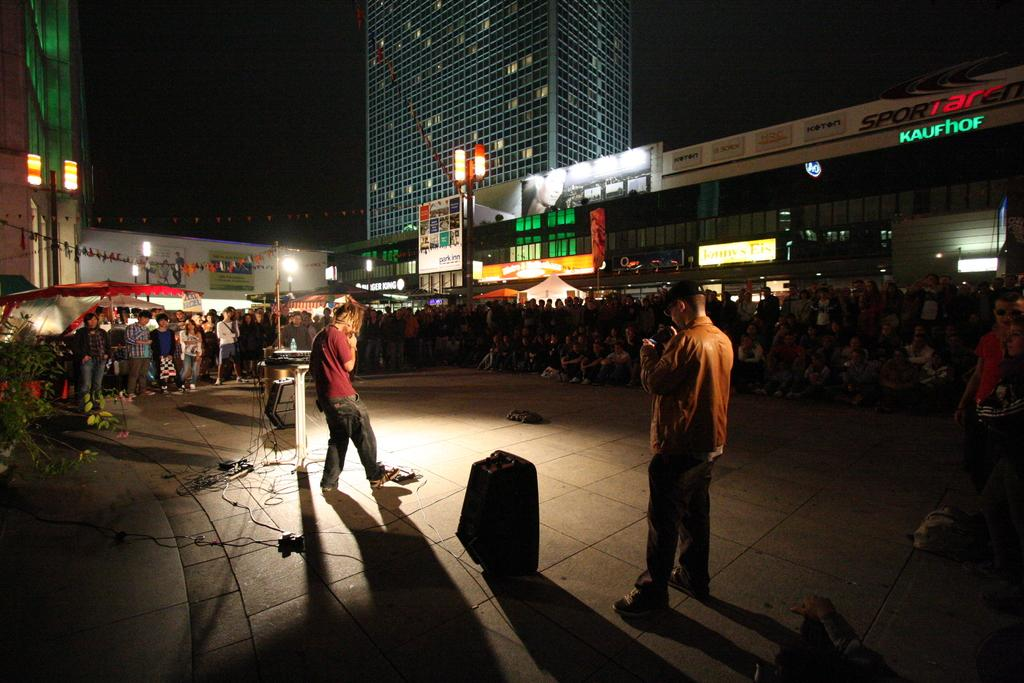How many people are present in the image? There are two persons standing in the image, and there are people sitting and standing, so the total number of people is not specified. What are the people in the image doing? The people in the image are standing and sitting. What can be seen in the background of the image? There are buildings visible in the image. What type of illumination is present in the image? There are lights present in the image. What type of bubble can be seen floating near the door in the image? There is no bubble or door present in the image. 